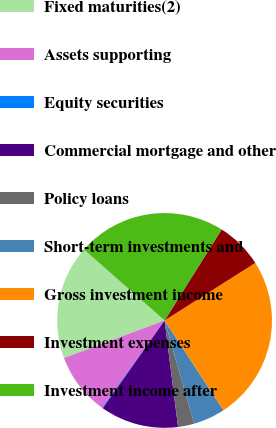<chart> <loc_0><loc_0><loc_500><loc_500><pie_chart><fcel>Fixed maturities(2)<fcel>Assets supporting<fcel>Equity securities<fcel>Commercial mortgage and other<fcel>Policy loans<fcel>Short-term investments and<fcel>Gross investment income<fcel>Investment expenses<fcel>Investment income after<nl><fcel>17.17%<fcel>9.43%<fcel>0.12%<fcel>11.76%<fcel>2.45%<fcel>4.78%<fcel>24.76%<fcel>7.1%<fcel>22.43%<nl></chart> 